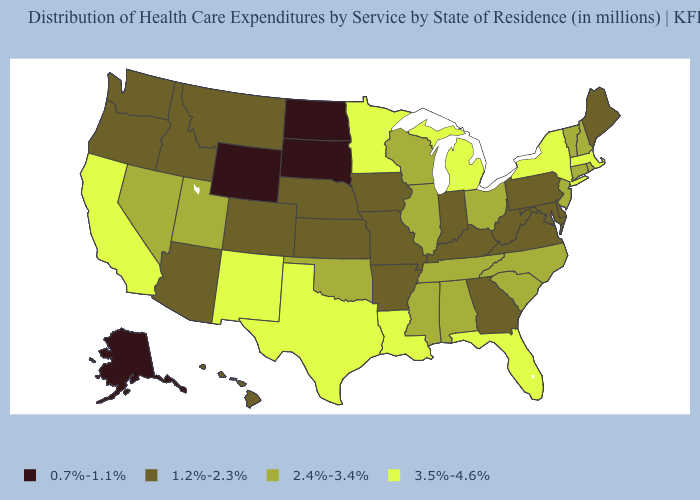Name the states that have a value in the range 3.5%-4.6%?
Answer briefly. California, Florida, Louisiana, Massachusetts, Michigan, Minnesota, New Mexico, New York, Texas. Does North Dakota have the lowest value in the USA?
Keep it brief. Yes. What is the value of Nevada?
Give a very brief answer. 2.4%-3.4%. Name the states that have a value in the range 1.2%-2.3%?
Short answer required. Arizona, Arkansas, Colorado, Delaware, Georgia, Hawaii, Idaho, Indiana, Iowa, Kansas, Kentucky, Maine, Maryland, Missouri, Montana, Nebraska, Oregon, Pennsylvania, Virginia, Washington, West Virginia. What is the value of Texas?
Write a very short answer. 3.5%-4.6%. What is the value of Nevada?
Be succinct. 2.4%-3.4%. Name the states that have a value in the range 2.4%-3.4%?
Write a very short answer. Alabama, Connecticut, Illinois, Mississippi, Nevada, New Hampshire, New Jersey, North Carolina, Ohio, Oklahoma, Rhode Island, South Carolina, Tennessee, Utah, Vermont, Wisconsin. Is the legend a continuous bar?
Short answer required. No. Does Vermont have the highest value in the USA?
Give a very brief answer. No. Does Georgia have a higher value than Washington?
Answer briefly. No. Among the states that border New Hampshire , which have the lowest value?
Answer briefly. Maine. Which states hav the highest value in the West?
Answer briefly. California, New Mexico. What is the lowest value in the Northeast?
Give a very brief answer. 1.2%-2.3%. What is the highest value in the USA?
Quick response, please. 3.5%-4.6%. Does New York have the highest value in the Northeast?
Quick response, please. Yes. 